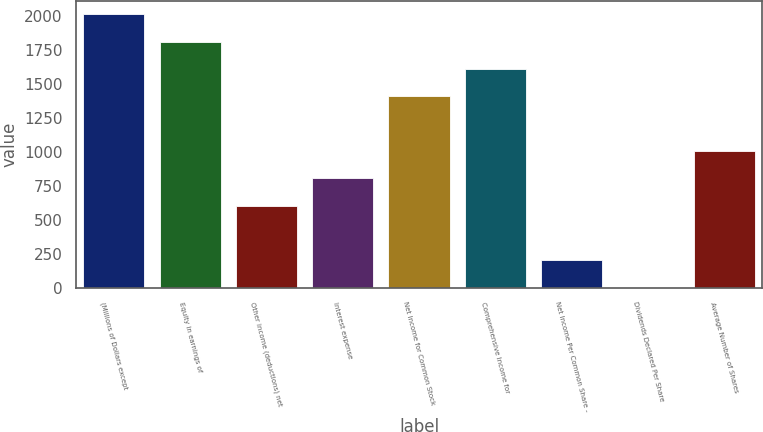Convert chart to OTSL. <chart><loc_0><loc_0><loc_500><loc_500><bar_chart><fcel>(Millions of Dollars except<fcel>Equity in earnings of<fcel>Other income (deductions) net<fcel>Interest expense<fcel>Net Income for Common Stock<fcel>Comprehensive Income for<fcel>Net Income Per Common Share -<fcel>Dividends Declared Per Share<fcel>Average Number of Shares<nl><fcel>2010<fcel>1809.22<fcel>604.66<fcel>805.42<fcel>1407.7<fcel>1608.46<fcel>203.14<fcel>2.38<fcel>1006.18<nl></chart> 